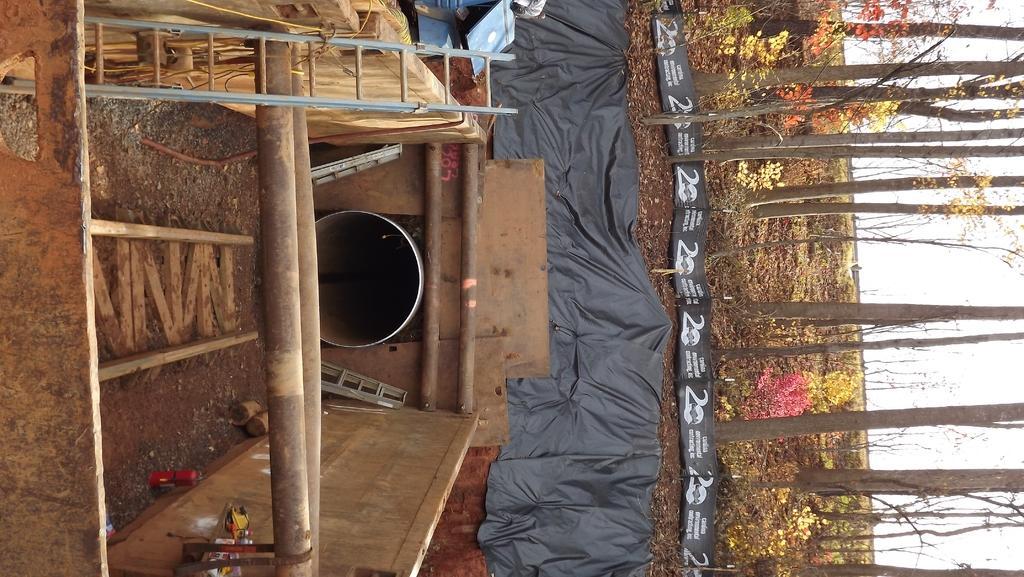Could you give a brief overview of what you see in this image? In this image, we can see wooden objects, rods, ladder, stands, black sheet, few objects and banners. Here we can see a big pipe. On the right side of the image, we can see trees, plants and sky. 